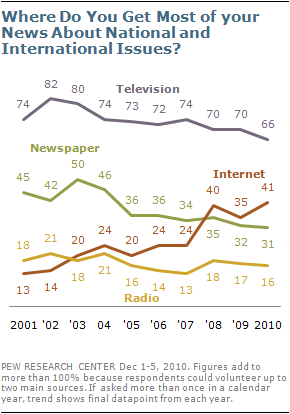Highlight a few significant elements in this photo. There are four news channels that have been mentioned. 